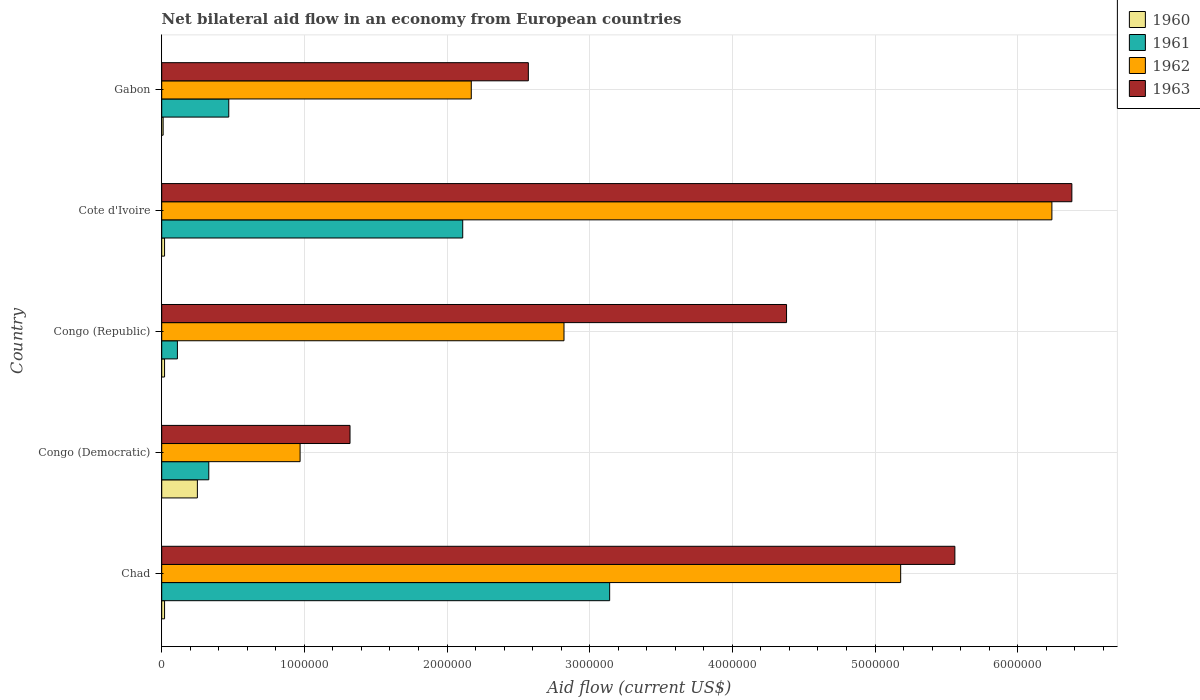How many groups of bars are there?
Provide a short and direct response. 5. Are the number of bars per tick equal to the number of legend labels?
Make the answer very short. Yes. Are the number of bars on each tick of the Y-axis equal?
Your answer should be compact. Yes. What is the label of the 1st group of bars from the top?
Your answer should be compact. Gabon. In how many cases, is the number of bars for a given country not equal to the number of legend labels?
Keep it short and to the point. 0. What is the net bilateral aid flow in 1963 in Chad?
Your answer should be compact. 5.56e+06. Across all countries, what is the maximum net bilateral aid flow in 1962?
Your answer should be very brief. 6.24e+06. In which country was the net bilateral aid flow in 1961 maximum?
Offer a very short reply. Chad. In which country was the net bilateral aid flow in 1960 minimum?
Your answer should be very brief. Gabon. What is the total net bilateral aid flow in 1961 in the graph?
Provide a short and direct response. 6.16e+06. What is the difference between the net bilateral aid flow in 1960 in Gabon and the net bilateral aid flow in 1962 in Cote d'Ivoire?
Give a very brief answer. -6.23e+06. What is the average net bilateral aid flow in 1963 per country?
Ensure brevity in your answer.  4.04e+06. What is the ratio of the net bilateral aid flow in 1962 in Congo (Democratic) to that in Congo (Republic)?
Provide a short and direct response. 0.34. Is the net bilateral aid flow in 1963 in Congo (Democratic) less than that in Congo (Republic)?
Offer a terse response. Yes. Is the difference between the net bilateral aid flow in 1960 in Congo (Democratic) and Cote d'Ivoire greater than the difference between the net bilateral aid flow in 1961 in Congo (Democratic) and Cote d'Ivoire?
Offer a terse response. Yes. What is the difference between the highest and the second highest net bilateral aid flow in 1963?
Your response must be concise. 8.20e+05. What is the difference between the highest and the lowest net bilateral aid flow in 1960?
Ensure brevity in your answer.  2.40e+05. What does the 2nd bar from the top in Cote d'Ivoire represents?
Your answer should be compact. 1962. What does the 2nd bar from the bottom in Congo (Republic) represents?
Provide a short and direct response. 1961. Is it the case that in every country, the sum of the net bilateral aid flow in 1962 and net bilateral aid flow in 1960 is greater than the net bilateral aid flow in 1961?
Your answer should be very brief. Yes. How many bars are there?
Your answer should be very brief. 20. What is the difference between two consecutive major ticks on the X-axis?
Ensure brevity in your answer.  1.00e+06. Are the values on the major ticks of X-axis written in scientific E-notation?
Offer a terse response. No. Does the graph contain any zero values?
Your answer should be very brief. No. Does the graph contain grids?
Provide a short and direct response. Yes. How are the legend labels stacked?
Give a very brief answer. Vertical. What is the title of the graph?
Offer a terse response. Net bilateral aid flow in an economy from European countries. Does "1963" appear as one of the legend labels in the graph?
Offer a very short reply. Yes. What is the Aid flow (current US$) of 1960 in Chad?
Provide a short and direct response. 2.00e+04. What is the Aid flow (current US$) of 1961 in Chad?
Offer a very short reply. 3.14e+06. What is the Aid flow (current US$) of 1962 in Chad?
Ensure brevity in your answer.  5.18e+06. What is the Aid flow (current US$) of 1963 in Chad?
Provide a succinct answer. 5.56e+06. What is the Aid flow (current US$) of 1961 in Congo (Democratic)?
Make the answer very short. 3.30e+05. What is the Aid flow (current US$) in 1962 in Congo (Democratic)?
Ensure brevity in your answer.  9.70e+05. What is the Aid flow (current US$) of 1963 in Congo (Democratic)?
Your answer should be very brief. 1.32e+06. What is the Aid flow (current US$) in 1961 in Congo (Republic)?
Provide a short and direct response. 1.10e+05. What is the Aid flow (current US$) in 1962 in Congo (Republic)?
Offer a very short reply. 2.82e+06. What is the Aid flow (current US$) of 1963 in Congo (Republic)?
Your answer should be compact. 4.38e+06. What is the Aid flow (current US$) of 1961 in Cote d'Ivoire?
Provide a short and direct response. 2.11e+06. What is the Aid flow (current US$) in 1962 in Cote d'Ivoire?
Make the answer very short. 6.24e+06. What is the Aid flow (current US$) of 1963 in Cote d'Ivoire?
Your response must be concise. 6.38e+06. What is the Aid flow (current US$) of 1961 in Gabon?
Your answer should be compact. 4.70e+05. What is the Aid flow (current US$) of 1962 in Gabon?
Ensure brevity in your answer.  2.17e+06. What is the Aid flow (current US$) in 1963 in Gabon?
Your answer should be compact. 2.57e+06. Across all countries, what is the maximum Aid flow (current US$) in 1960?
Ensure brevity in your answer.  2.50e+05. Across all countries, what is the maximum Aid flow (current US$) in 1961?
Give a very brief answer. 3.14e+06. Across all countries, what is the maximum Aid flow (current US$) in 1962?
Offer a very short reply. 6.24e+06. Across all countries, what is the maximum Aid flow (current US$) of 1963?
Offer a terse response. 6.38e+06. Across all countries, what is the minimum Aid flow (current US$) of 1961?
Your answer should be compact. 1.10e+05. Across all countries, what is the minimum Aid flow (current US$) of 1962?
Ensure brevity in your answer.  9.70e+05. Across all countries, what is the minimum Aid flow (current US$) of 1963?
Ensure brevity in your answer.  1.32e+06. What is the total Aid flow (current US$) of 1961 in the graph?
Make the answer very short. 6.16e+06. What is the total Aid flow (current US$) of 1962 in the graph?
Provide a succinct answer. 1.74e+07. What is the total Aid flow (current US$) in 1963 in the graph?
Your answer should be very brief. 2.02e+07. What is the difference between the Aid flow (current US$) in 1961 in Chad and that in Congo (Democratic)?
Make the answer very short. 2.81e+06. What is the difference between the Aid flow (current US$) of 1962 in Chad and that in Congo (Democratic)?
Make the answer very short. 4.21e+06. What is the difference between the Aid flow (current US$) of 1963 in Chad and that in Congo (Democratic)?
Your response must be concise. 4.24e+06. What is the difference between the Aid flow (current US$) of 1960 in Chad and that in Congo (Republic)?
Your response must be concise. 0. What is the difference between the Aid flow (current US$) in 1961 in Chad and that in Congo (Republic)?
Your answer should be compact. 3.03e+06. What is the difference between the Aid flow (current US$) in 1962 in Chad and that in Congo (Republic)?
Your response must be concise. 2.36e+06. What is the difference between the Aid flow (current US$) of 1963 in Chad and that in Congo (Republic)?
Your response must be concise. 1.18e+06. What is the difference between the Aid flow (current US$) of 1961 in Chad and that in Cote d'Ivoire?
Provide a short and direct response. 1.03e+06. What is the difference between the Aid flow (current US$) of 1962 in Chad and that in Cote d'Ivoire?
Give a very brief answer. -1.06e+06. What is the difference between the Aid flow (current US$) in 1963 in Chad and that in Cote d'Ivoire?
Your response must be concise. -8.20e+05. What is the difference between the Aid flow (current US$) of 1960 in Chad and that in Gabon?
Provide a short and direct response. 10000. What is the difference between the Aid flow (current US$) in 1961 in Chad and that in Gabon?
Your answer should be compact. 2.67e+06. What is the difference between the Aid flow (current US$) of 1962 in Chad and that in Gabon?
Your answer should be very brief. 3.01e+06. What is the difference between the Aid flow (current US$) of 1963 in Chad and that in Gabon?
Offer a very short reply. 2.99e+06. What is the difference between the Aid flow (current US$) in 1960 in Congo (Democratic) and that in Congo (Republic)?
Ensure brevity in your answer.  2.30e+05. What is the difference between the Aid flow (current US$) of 1961 in Congo (Democratic) and that in Congo (Republic)?
Give a very brief answer. 2.20e+05. What is the difference between the Aid flow (current US$) of 1962 in Congo (Democratic) and that in Congo (Republic)?
Ensure brevity in your answer.  -1.85e+06. What is the difference between the Aid flow (current US$) in 1963 in Congo (Democratic) and that in Congo (Republic)?
Keep it short and to the point. -3.06e+06. What is the difference between the Aid flow (current US$) in 1960 in Congo (Democratic) and that in Cote d'Ivoire?
Your response must be concise. 2.30e+05. What is the difference between the Aid flow (current US$) in 1961 in Congo (Democratic) and that in Cote d'Ivoire?
Your answer should be very brief. -1.78e+06. What is the difference between the Aid flow (current US$) in 1962 in Congo (Democratic) and that in Cote d'Ivoire?
Offer a very short reply. -5.27e+06. What is the difference between the Aid flow (current US$) of 1963 in Congo (Democratic) and that in Cote d'Ivoire?
Offer a very short reply. -5.06e+06. What is the difference between the Aid flow (current US$) of 1960 in Congo (Democratic) and that in Gabon?
Keep it short and to the point. 2.40e+05. What is the difference between the Aid flow (current US$) in 1961 in Congo (Democratic) and that in Gabon?
Your answer should be very brief. -1.40e+05. What is the difference between the Aid flow (current US$) of 1962 in Congo (Democratic) and that in Gabon?
Offer a terse response. -1.20e+06. What is the difference between the Aid flow (current US$) of 1963 in Congo (Democratic) and that in Gabon?
Your answer should be compact. -1.25e+06. What is the difference between the Aid flow (current US$) of 1962 in Congo (Republic) and that in Cote d'Ivoire?
Provide a succinct answer. -3.42e+06. What is the difference between the Aid flow (current US$) in 1961 in Congo (Republic) and that in Gabon?
Offer a terse response. -3.60e+05. What is the difference between the Aid flow (current US$) of 1962 in Congo (Republic) and that in Gabon?
Your answer should be compact. 6.50e+05. What is the difference between the Aid flow (current US$) of 1963 in Congo (Republic) and that in Gabon?
Offer a terse response. 1.81e+06. What is the difference between the Aid flow (current US$) of 1961 in Cote d'Ivoire and that in Gabon?
Keep it short and to the point. 1.64e+06. What is the difference between the Aid flow (current US$) of 1962 in Cote d'Ivoire and that in Gabon?
Keep it short and to the point. 4.07e+06. What is the difference between the Aid flow (current US$) of 1963 in Cote d'Ivoire and that in Gabon?
Give a very brief answer. 3.81e+06. What is the difference between the Aid flow (current US$) in 1960 in Chad and the Aid flow (current US$) in 1961 in Congo (Democratic)?
Your answer should be very brief. -3.10e+05. What is the difference between the Aid flow (current US$) in 1960 in Chad and the Aid flow (current US$) in 1962 in Congo (Democratic)?
Provide a succinct answer. -9.50e+05. What is the difference between the Aid flow (current US$) of 1960 in Chad and the Aid flow (current US$) of 1963 in Congo (Democratic)?
Your answer should be very brief. -1.30e+06. What is the difference between the Aid flow (current US$) in 1961 in Chad and the Aid flow (current US$) in 1962 in Congo (Democratic)?
Provide a short and direct response. 2.17e+06. What is the difference between the Aid flow (current US$) of 1961 in Chad and the Aid flow (current US$) of 1963 in Congo (Democratic)?
Your answer should be compact. 1.82e+06. What is the difference between the Aid flow (current US$) in 1962 in Chad and the Aid flow (current US$) in 1963 in Congo (Democratic)?
Provide a short and direct response. 3.86e+06. What is the difference between the Aid flow (current US$) of 1960 in Chad and the Aid flow (current US$) of 1961 in Congo (Republic)?
Offer a very short reply. -9.00e+04. What is the difference between the Aid flow (current US$) of 1960 in Chad and the Aid flow (current US$) of 1962 in Congo (Republic)?
Offer a terse response. -2.80e+06. What is the difference between the Aid flow (current US$) in 1960 in Chad and the Aid flow (current US$) in 1963 in Congo (Republic)?
Keep it short and to the point. -4.36e+06. What is the difference between the Aid flow (current US$) in 1961 in Chad and the Aid flow (current US$) in 1962 in Congo (Republic)?
Give a very brief answer. 3.20e+05. What is the difference between the Aid flow (current US$) of 1961 in Chad and the Aid flow (current US$) of 1963 in Congo (Republic)?
Offer a terse response. -1.24e+06. What is the difference between the Aid flow (current US$) of 1960 in Chad and the Aid flow (current US$) of 1961 in Cote d'Ivoire?
Provide a short and direct response. -2.09e+06. What is the difference between the Aid flow (current US$) of 1960 in Chad and the Aid flow (current US$) of 1962 in Cote d'Ivoire?
Ensure brevity in your answer.  -6.22e+06. What is the difference between the Aid flow (current US$) of 1960 in Chad and the Aid flow (current US$) of 1963 in Cote d'Ivoire?
Provide a succinct answer. -6.36e+06. What is the difference between the Aid flow (current US$) of 1961 in Chad and the Aid flow (current US$) of 1962 in Cote d'Ivoire?
Offer a terse response. -3.10e+06. What is the difference between the Aid flow (current US$) of 1961 in Chad and the Aid flow (current US$) of 1963 in Cote d'Ivoire?
Offer a terse response. -3.24e+06. What is the difference between the Aid flow (current US$) in 1962 in Chad and the Aid flow (current US$) in 1963 in Cote d'Ivoire?
Make the answer very short. -1.20e+06. What is the difference between the Aid flow (current US$) in 1960 in Chad and the Aid flow (current US$) in 1961 in Gabon?
Ensure brevity in your answer.  -4.50e+05. What is the difference between the Aid flow (current US$) of 1960 in Chad and the Aid flow (current US$) of 1962 in Gabon?
Provide a short and direct response. -2.15e+06. What is the difference between the Aid flow (current US$) in 1960 in Chad and the Aid flow (current US$) in 1963 in Gabon?
Keep it short and to the point. -2.55e+06. What is the difference between the Aid flow (current US$) in 1961 in Chad and the Aid flow (current US$) in 1962 in Gabon?
Offer a terse response. 9.70e+05. What is the difference between the Aid flow (current US$) of 1961 in Chad and the Aid flow (current US$) of 1963 in Gabon?
Provide a short and direct response. 5.70e+05. What is the difference between the Aid flow (current US$) of 1962 in Chad and the Aid flow (current US$) of 1963 in Gabon?
Offer a very short reply. 2.61e+06. What is the difference between the Aid flow (current US$) in 1960 in Congo (Democratic) and the Aid flow (current US$) in 1961 in Congo (Republic)?
Provide a short and direct response. 1.40e+05. What is the difference between the Aid flow (current US$) of 1960 in Congo (Democratic) and the Aid flow (current US$) of 1962 in Congo (Republic)?
Your answer should be compact. -2.57e+06. What is the difference between the Aid flow (current US$) in 1960 in Congo (Democratic) and the Aid flow (current US$) in 1963 in Congo (Republic)?
Your answer should be very brief. -4.13e+06. What is the difference between the Aid flow (current US$) of 1961 in Congo (Democratic) and the Aid flow (current US$) of 1962 in Congo (Republic)?
Offer a very short reply. -2.49e+06. What is the difference between the Aid flow (current US$) in 1961 in Congo (Democratic) and the Aid flow (current US$) in 1963 in Congo (Republic)?
Offer a terse response. -4.05e+06. What is the difference between the Aid flow (current US$) in 1962 in Congo (Democratic) and the Aid flow (current US$) in 1963 in Congo (Republic)?
Offer a very short reply. -3.41e+06. What is the difference between the Aid flow (current US$) of 1960 in Congo (Democratic) and the Aid flow (current US$) of 1961 in Cote d'Ivoire?
Keep it short and to the point. -1.86e+06. What is the difference between the Aid flow (current US$) in 1960 in Congo (Democratic) and the Aid flow (current US$) in 1962 in Cote d'Ivoire?
Your answer should be compact. -5.99e+06. What is the difference between the Aid flow (current US$) of 1960 in Congo (Democratic) and the Aid flow (current US$) of 1963 in Cote d'Ivoire?
Your answer should be very brief. -6.13e+06. What is the difference between the Aid flow (current US$) of 1961 in Congo (Democratic) and the Aid flow (current US$) of 1962 in Cote d'Ivoire?
Your response must be concise. -5.91e+06. What is the difference between the Aid flow (current US$) of 1961 in Congo (Democratic) and the Aid flow (current US$) of 1963 in Cote d'Ivoire?
Provide a short and direct response. -6.05e+06. What is the difference between the Aid flow (current US$) of 1962 in Congo (Democratic) and the Aid flow (current US$) of 1963 in Cote d'Ivoire?
Give a very brief answer. -5.41e+06. What is the difference between the Aid flow (current US$) of 1960 in Congo (Democratic) and the Aid flow (current US$) of 1961 in Gabon?
Provide a succinct answer. -2.20e+05. What is the difference between the Aid flow (current US$) in 1960 in Congo (Democratic) and the Aid flow (current US$) in 1962 in Gabon?
Give a very brief answer. -1.92e+06. What is the difference between the Aid flow (current US$) of 1960 in Congo (Democratic) and the Aid flow (current US$) of 1963 in Gabon?
Give a very brief answer. -2.32e+06. What is the difference between the Aid flow (current US$) of 1961 in Congo (Democratic) and the Aid flow (current US$) of 1962 in Gabon?
Make the answer very short. -1.84e+06. What is the difference between the Aid flow (current US$) in 1961 in Congo (Democratic) and the Aid flow (current US$) in 1963 in Gabon?
Ensure brevity in your answer.  -2.24e+06. What is the difference between the Aid flow (current US$) in 1962 in Congo (Democratic) and the Aid flow (current US$) in 1963 in Gabon?
Keep it short and to the point. -1.60e+06. What is the difference between the Aid flow (current US$) of 1960 in Congo (Republic) and the Aid flow (current US$) of 1961 in Cote d'Ivoire?
Make the answer very short. -2.09e+06. What is the difference between the Aid flow (current US$) in 1960 in Congo (Republic) and the Aid flow (current US$) in 1962 in Cote d'Ivoire?
Keep it short and to the point. -6.22e+06. What is the difference between the Aid flow (current US$) of 1960 in Congo (Republic) and the Aid flow (current US$) of 1963 in Cote d'Ivoire?
Provide a succinct answer. -6.36e+06. What is the difference between the Aid flow (current US$) of 1961 in Congo (Republic) and the Aid flow (current US$) of 1962 in Cote d'Ivoire?
Provide a short and direct response. -6.13e+06. What is the difference between the Aid flow (current US$) in 1961 in Congo (Republic) and the Aid flow (current US$) in 1963 in Cote d'Ivoire?
Provide a short and direct response. -6.27e+06. What is the difference between the Aid flow (current US$) in 1962 in Congo (Republic) and the Aid flow (current US$) in 1963 in Cote d'Ivoire?
Ensure brevity in your answer.  -3.56e+06. What is the difference between the Aid flow (current US$) of 1960 in Congo (Republic) and the Aid flow (current US$) of 1961 in Gabon?
Ensure brevity in your answer.  -4.50e+05. What is the difference between the Aid flow (current US$) in 1960 in Congo (Republic) and the Aid flow (current US$) in 1962 in Gabon?
Your response must be concise. -2.15e+06. What is the difference between the Aid flow (current US$) of 1960 in Congo (Republic) and the Aid flow (current US$) of 1963 in Gabon?
Give a very brief answer. -2.55e+06. What is the difference between the Aid flow (current US$) of 1961 in Congo (Republic) and the Aid flow (current US$) of 1962 in Gabon?
Offer a very short reply. -2.06e+06. What is the difference between the Aid flow (current US$) in 1961 in Congo (Republic) and the Aid flow (current US$) in 1963 in Gabon?
Ensure brevity in your answer.  -2.46e+06. What is the difference between the Aid flow (current US$) in 1960 in Cote d'Ivoire and the Aid flow (current US$) in 1961 in Gabon?
Offer a terse response. -4.50e+05. What is the difference between the Aid flow (current US$) of 1960 in Cote d'Ivoire and the Aid flow (current US$) of 1962 in Gabon?
Offer a terse response. -2.15e+06. What is the difference between the Aid flow (current US$) of 1960 in Cote d'Ivoire and the Aid flow (current US$) of 1963 in Gabon?
Give a very brief answer. -2.55e+06. What is the difference between the Aid flow (current US$) of 1961 in Cote d'Ivoire and the Aid flow (current US$) of 1963 in Gabon?
Your answer should be very brief. -4.60e+05. What is the difference between the Aid flow (current US$) in 1962 in Cote d'Ivoire and the Aid flow (current US$) in 1963 in Gabon?
Keep it short and to the point. 3.67e+06. What is the average Aid flow (current US$) of 1960 per country?
Your response must be concise. 6.40e+04. What is the average Aid flow (current US$) in 1961 per country?
Your answer should be very brief. 1.23e+06. What is the average Aid flow (current US$) in 1962 per country?
Your answer should be very brief. 3.48e+06. What is the average Aid flow (current US$) of 1963 per country?
Ensure brevity in your answer.  4.04e+06. What is the difference between the Aid flow (current US$) of 1960 and Aid flow (current US$) of 1961 in Chad?
Give a very brief answer. -3.12e+06. What is the difference between the Aid flow (current US$) of 1960 and Aid flow (current US$) of 1962 in Chad?
Your answer should be compact. -5.16e+06. What is the difference between the Aid flow (current US$) in 1960 and Aid flow (current US$) in 1963 in Chad?
Your answer should be very brief. -5.54e+06. What is the difference between the Aid flow (current US$) in 1961 and Aid flow (current US$) in 1962 in Chad?
Keep it short and to the point. -2.04e+06. What is the difference between the Aid flow (current US$) of 1961 and Aid flow (current US$) of 1963 in Chad?
Your answer should be compact. -2.42e+06. What is the difference between the Aid flow (current US$) of 1962 and Aid flow (current US$) of 1963 in Chad?
Your answer should be compact. -3.80e+05. What is the difference between the Aid flow (current US$) of 1960 and Aid flow (current US$) of 1962 in Congo (Democratic)?
Give a very brief answer. -7.20e+05. What is the difference between the Aid flow (current US$) in 1960 and Aid flow (current US$) in 1963 in Congo (Democratic)?
Offer a terse response. -1.07e+06. What is the difference between the Aid flow (current US$) of 1961 and Aid flow (current US$) of 1962 in Congo (Democratic)?
Your response must be concise. -6.40e+05. What is the difference between the Aid flow (current US$) of 1961 and Aid flow (current US$) of 1963 in Congo (Democratic)?
Offer a terse response. -9.90e+05. What is the difference between the Aid flow (current US$) of 1962 and Aid flow (current US$) of 1963 in Congo (Democratic)?
Provide a succinct answer. -3.50e+05. What is the difference between the Aid flow (current US$) of 1960 and Aid flow (current US$) of 1961 in Congo (Republic)?
Keep it short and to the point. -9.00e+04. What is the difference between the Aid flow (current US$) of 1960 and Aid flow (current US$) of 1962 in Congo (Republic)?
Your answer should be very brief. -2.80e+06. What is the difference between the Aid flow (current US$) in 1960 and Aid flow (current US$) in 1963 in Congo (Republic)?
Make the answer very short. -4.36e+06. What is the difference between the Aid flow (current US$) of 1961 and Aid flow (current US$) of 1962 in Congo (Republic)?
Your answer should be compact. -2.71e+06. What is the difference between the Aid flow (current US$) in 1961 and Aid flow (current US$) in 1963 in Congo (Republic)?
Your answer should be compact. -4.27e+06. What is the difference between the Aid flow (current US$) of 1962 and Aid flow (current US$) of 1963 in Congo (Republic)?
Ensure brevity in your answer.  -1.56e+06. What is the difference between the Aid flow (current US$) of 1960 and Aid flow (current US$) of 1961 in Cote d'Ivoire?
Your answer should be compact. -2.09e+06. What is the difference between the Aid flow (current US$) in 1960 and Aid flow (current US$) in 1962 in Cote d'Ivoire?
Give a very brief answer. -6.22e+06. What is the difference between the Aid flow (current US$) of 1960 and Aid flow (current US$) of 1963 in Cote d'Ivoire?
Your answer should be compact. -6.36e+06. What is the difference between the Aid flow (current US$) in 1961 and Aid flow (current US$) in 1962 in Cote d'Ivoire?
Your answer should be very brief. -4.13e+06. What is the difference between the Aid flow (current US$) in 1961 and Aid flow (current US$) in 1963 in Cote d'Ivoire?
Ensure brevity in your answer.  -4.27e+06. What is the difference between the Aid flow (current US$) of 1962 and Aid flow (current US$) of 1963 in Cote d'Ivoire?
Your response must be concise. -1.40e+05. What is the difference between the Aid flow (current US$) of 1960 and Aid flow (current US$) of 1961 in Gabon?
Keep it short and to the point. -4.60e+05. What is the difference between the Aid flow (current US$) in 1960 and Aid flow (current US$) in 1962 in Gabon?
Give a very brief answer. -2.16e+06. What is the difference between the Aid flow (current US$) in 1960 and Aid flow (current US$) in 1963 in Gabon?
Make the answer very short. -2.56e+06. What is the difference between the Aid flow (current US$) in 1961 and Aid flow (current US$) in 1962 in Gabon?
Provide a succinct answer. -1.70e+06. What is the difference between the Aid flow (current US$) in 1961 and Aid flow (current US$) in 1963 in Gabon?
Your answer should be very brief. -2.10e+06. What is the difference between the Aid flow (current US$) of 1962 and Aid flow (current US$) of 1963 in Gabon?
Your answer should be compact. -4.00e+05. What is the ratio of the Aid flow (current US$) in 1960 in Chad to that in Congo (Democratic)?
Give a very brief answer. 0.08. What is the ratio of the Aid flow (current US$) of 1961 in Chad to that in Congo (Democratic)?
Make the answer very short. 9.52. What is the ratio of the Aid flow (current US$) in 1962 in Chad to that in Congo (Democratic)?
Make the answer very short. 5.34. What is the ratio of the Aid flow (current US$) of 1963 in Chad to that in Congo (Democratic)?
Your response must be concise. 4.21. What is the ratio of the Aid flow (current US$) of 1961 in Chad to that in Congo (Republic)?
Provide a succinct answer. 28.55. What is the ratio of the Aid flow (current US$) in 1962 in Chad to that in Congo (Republic)?
Provide a short and direct response. 1.84. What is the ratio of the Aid flow (current US$) of 1963 in Chad to that in Congo (Republic)?
Offer a very short reply. 1.27. What is the ratio of the Aid flow (current US$) of 1960 in Chad to that in Cote d'Ivoire?
Offer a terse response. 1. What is the ratio of the Aid flow (current US$) in 1961 in Chad to that in Cote d'Ivoire?
Your answer should be very brief. 1.49. What is the ratio of the Aid flow (current US$) in 1962 in Chad to that in Cote d'Ivoire?
Keep it short and to the point. 0.83. What is the ratio of the Aid flow (current US$) of 1963 in Chad to that in Cote d'Ivoire?
Offer a terse response. 0.87. What is the ratio of the Aid flow (current US$) of 1960 in Chad to that in Gabon?
Your answer should be very brief. 2. What is the ratio of the Aid flow (current US$) in 1961 in Chad to that in Gabon?
Your response must be concise. 6.68. What is the ratio of the Aid flow (current US$) of 1962 in Chad to that in Gabon?
Provide a short and direct response. 2.39. What is the ratio of the Aid flow (current US$) in 1963 in Chad to that in Gabon?
Offer a terse response. 2.16. What is the ratio of the Aid flow (current US$) in 1960 in Congo (Democratic) to that in Congo (Republic)?
Keep it short and to the point. 12.5. What is the ratio of the Aid flow (current US$) of 1962 in Congo (Democratic) to that in Congo (Republic)?
Offer a very short reply. 0.34. What is the ratio of the Aid flow (current US$) of 1963 in Congo (Democratic) to that in Congo (Republic)?
Offer a very short reply. 0.3. What is the ratio of the Aid flow (current US$) in 1961 in Congo (Democratic) to that in Cote d'Ivoire?
Your answer should be very brief. 0.16. What is the ratio of the Aid flow (current US$) of 1962 in Congo (Democratic) to that in Cote d'Ivoire?
Give a very brief answer. 0.16. What is the ratio of the Aid flow (current US$) of 1963 in Congo (Democratic) to that in Cote d'Ivoire?
Make the answer very short. 0.21. What is the ratio of the Aid flow (current US$) of 1960 in Congo (Democratic) to that in Gabon?
Your answer should be compact. 25. What is the ratio of the Aid flow (current US$) in 1961 in Congo (Democratic) to that in Gabon?
Give a very brief answer. 0.7. What is the ratio of the Aid flow (current US$) of 1962 in Congo (Democratic) to that in Gabon?
Ensure brevity in your answer.  0.45. What is the ratio of the Aid flow (current US$) in 1963 in Congo (Democratic) to that in Gabon?
Make the answer very short. 0.51. What is the ratio of the Aid flow (current US$) of 1961 in Congo (Republic) to that in Cote d'Ivoire?
Provide a short and direct response. 0.05. What is the ratio of the Aid flow (current US$) in 1962 in Congo (Republic) to that in Cote d'Ivoire?
Provide a succinct answer. 0.45. What is the ratio of the Aid flow (current US$) in 1963 in Congo (Republic) to that in Cote d'Ivoire?
Offer a very short reply. 0.69. What is the ratio of the Aid flow (current US$) in 1960 in Congo (Republic) to that in Gabon?
Offer a terse response. 2. What is the ratio of the Aid flow (current US$) in 1961 in Congo (Republic) to that in Gabon?
Give a very brief answer. 0.23. What is the ratio of the Aid flow (current US$) in 1962 in Congo (Republic) to that in Gabon?
Give a very brief answer. 1.3. What is the ratio of the Aid flow (current US$) of 1963 in Congo (Republic) to that in Gabon?
Keep it short and to the point. 1.7. What is the ratio of the Aid flow (current US$) of 1961 in Cote d'Ivoire to that in Gabon?
Keep it short and to the point. 4.49. What is the ratio of the Aid flow (current US$) of 1962 in Cote d'Ivoire to that in Gabon?
Provide a succinct answer. 2.88. What is the ratio of the Aid flow (current US$) of 1963 in Cote d'Ivoire to that in Gabon?
Your response must be concise. 2.48. What is the difference between the highest and the second highest Aid flow (current US$) in 1961?
Provide a short and direct response. 1.03e+06. What is the difference between the highest and the second highest Aid flow (current US$) of 1962?
Offer a very short reply. 1.06e+06. What is the difference between the highest and the second highest Aid flow (current US$) of 1963?
Give a very brief answer. 8.20e+05. What is the difference between the highest and the lowest Aid flow (current US$) of 1960?
Ensure brevity in your answer.  2.40e+05. What is the difference between the highest and the lowest Aid flow (current US$) in 1961?
Offer a very short reply. 3.03e+06. What is the difference between the highest and the lowest Aid flow (current US$) in 1962?
Provide a short and direct response. 5.27e+06. What is the difference between the highest and the lowest Aid flow (current US$) in 1963?
Ensure brevity in your answer.  5.06e+06. 